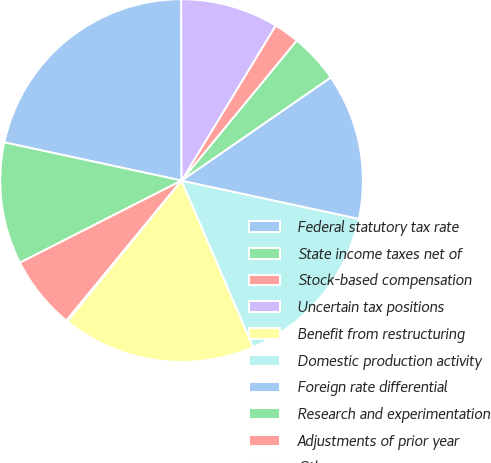Convert chart to OTSL. <chart><loc_0><loc_0><loc_500><loc_500><pie_chart><fcel>Federal statutory tax rate<fcel>State income taxes net of<fcel>Stock-based compensation<fcel>Uncertain tax positions<fcel>Benefit from restructuring<fcel>Domestic production activity<fcel>Foreign rate differential<fcel>Research and experimentation<fcel>Adjustments of prior year<fcel>Other<nl><fcel>21.59%<fcel>10.86%<fcel>6.56%<fcel>0.12%<fcel>17.3%<fcel>15.15%<fcel>13.01%<fcel>4.42%<fcel>2.27%<fcel>8.71%<nl></chart> 